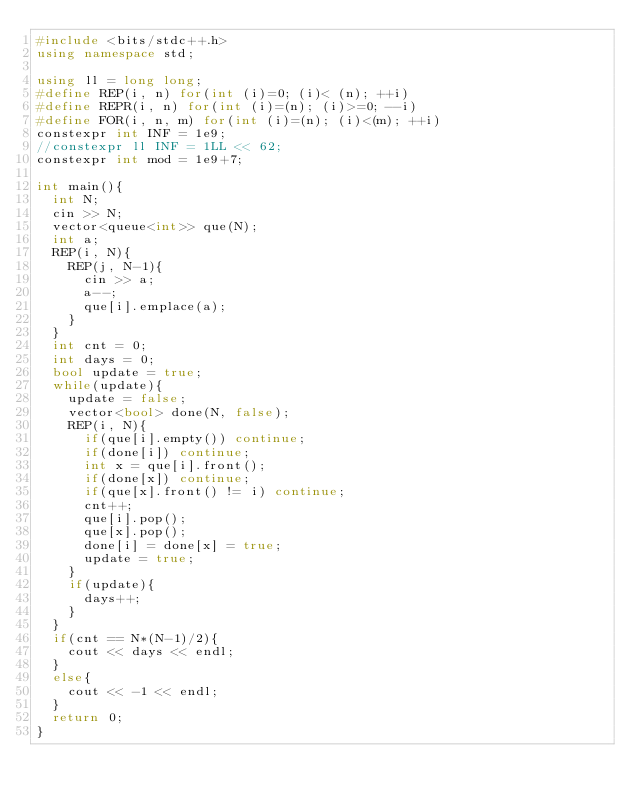<code> <loc_0><loc_0><loc_500><loc_500><_C++_>#include <bits/stdc++.h>
using namespace std;

using ll = long long;
#define REP(i, n) for(int (i)=0; (i)< (n); ++i)
#define REPR(i, n) for(int (i)=(n); (i)>=0; --i)
#define FOR(i, n, m) for(int (i)=(n); (i)<(m); ++i)
constexpr int INF = 1e9;
//constexpr ll INF = 1LL << 62;
constexpr int mod = 1e9+7;

int main(){
  int N;
  cin >> N;
  vector<queue<int>> que(N);
  int a;
  REP(i, N){
    REP(j, N-1){
      cin >> a;
      a--;
      que[i].emplace(a);
    }
  }
  int cnt = 0;
  int days = 0;
  bool update = true;
  while(update){
    update = false;
    vector<bool> done(N, false);
    REP(i, N){
      if(que[i].empty()) continue;
      if(done[i]) continue;
      int x = que[i].front();
      if(done[x]) continue;
      if(que[x].front() != i) continue;
      cnt++;
      que[i].pop();
      que[x].pop();
      done[i] = done[x] = true;
      update = true;
    }
    if(update){
      days++;
    }
  }
  if(cnt == N*(N-1)/2){
    cout << days << endl;
  }
  else{
    cout << -1 << endl;
  }
  return 0;
}
</code> 